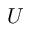Convert formula to latex. <formula><loc_0><loc_0><loc_500><loc_500>U</formula> 